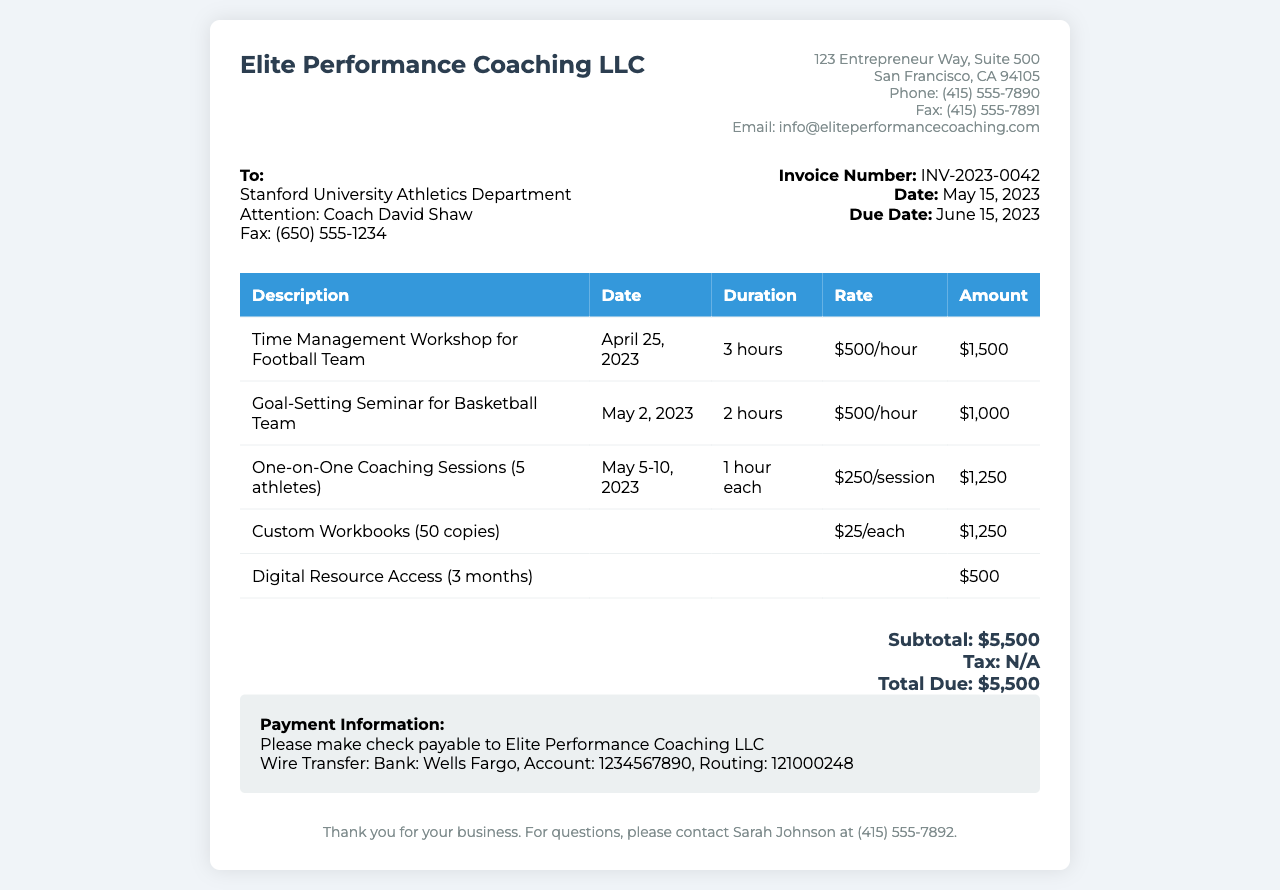What is the invoice number? The invoice number is clearly stated in the document as INV-2023-0042.
Answer: INV-2023-0042 Who is the recipient of the invoice? The recipient of the invoice is the Stanford University Athletics Department, specifically addressed to Coach David Shaw.
Answer: Stanford University Athletics Department What is the total amount due? The total amount due is the sum of all listed charges, which is stated as $5,500.
Answer: $5,500 What services were provided on April 25, 2023? The service provided on that date is specified as a Time Management Workshop for the Football Team.
Answer: Time Management Workshop for Football Team How many one-on-one coaching sessions were held? The document states that there were five one-on-one coaching sessions provided, each lasting 1 hour.
Answer: 5 athletes What is the date the invoice is due? The due date for the invoice is indicated as June 15, 2023.
Answer: June 15, 2023 What is the rate for the coaching sessions? The rate for the one-on-one coaching sessions is listed as $250 per session.
Answer: $250/session What is the address of Elite Performance Coaching LLC? The address is specified in the document as 123 Entrepreneur Way, Suite 500, San Francisco, CA 94105.
Answer: 123 Entrepreneur Way, Suite 500, San Francisco, CA 94105 What is provided in the digital resource access? The document mentions that access to digital resources for three months is provided.
Answer: 3 months 